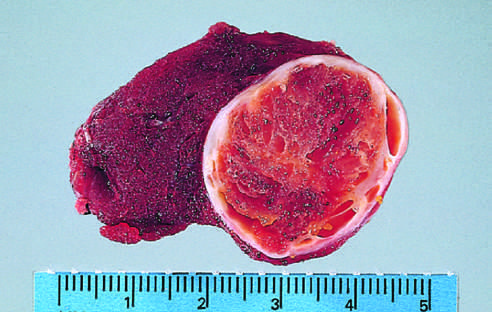s the tumor composed of cells with abundant eosinophilic cytoplasm and small regular nuclei on this high-power view?
Answer the question using a single word or phrase. Yes 